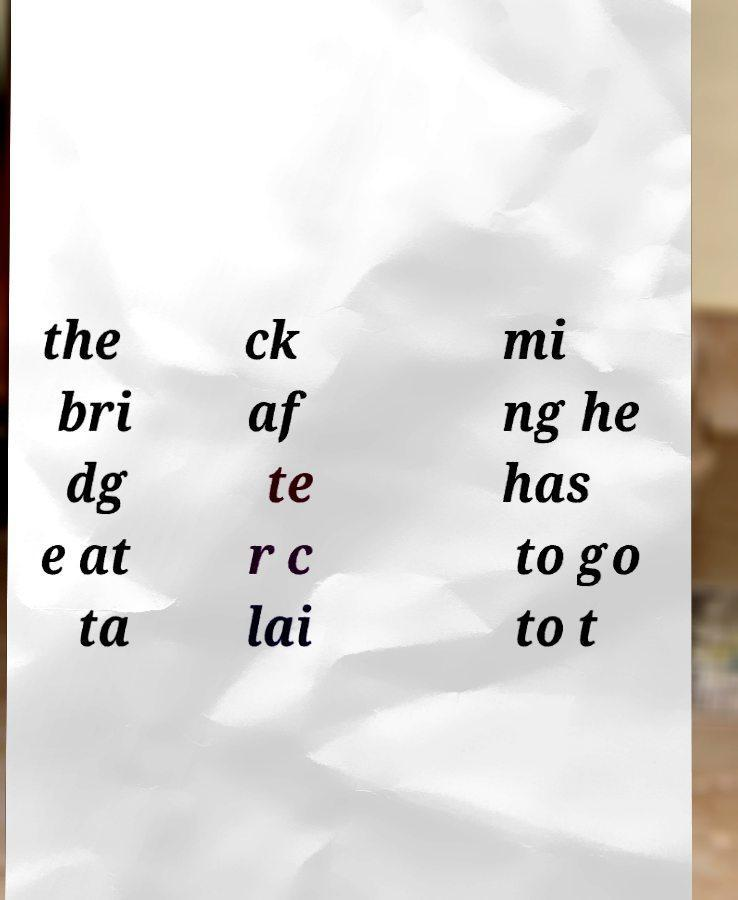Can you read and provide the text displayed in the image?This photo seems to have some interesting text. Can you extract and type it out for me? the bri dg e at ta ck af te r c lai mi ng he has to go to t 